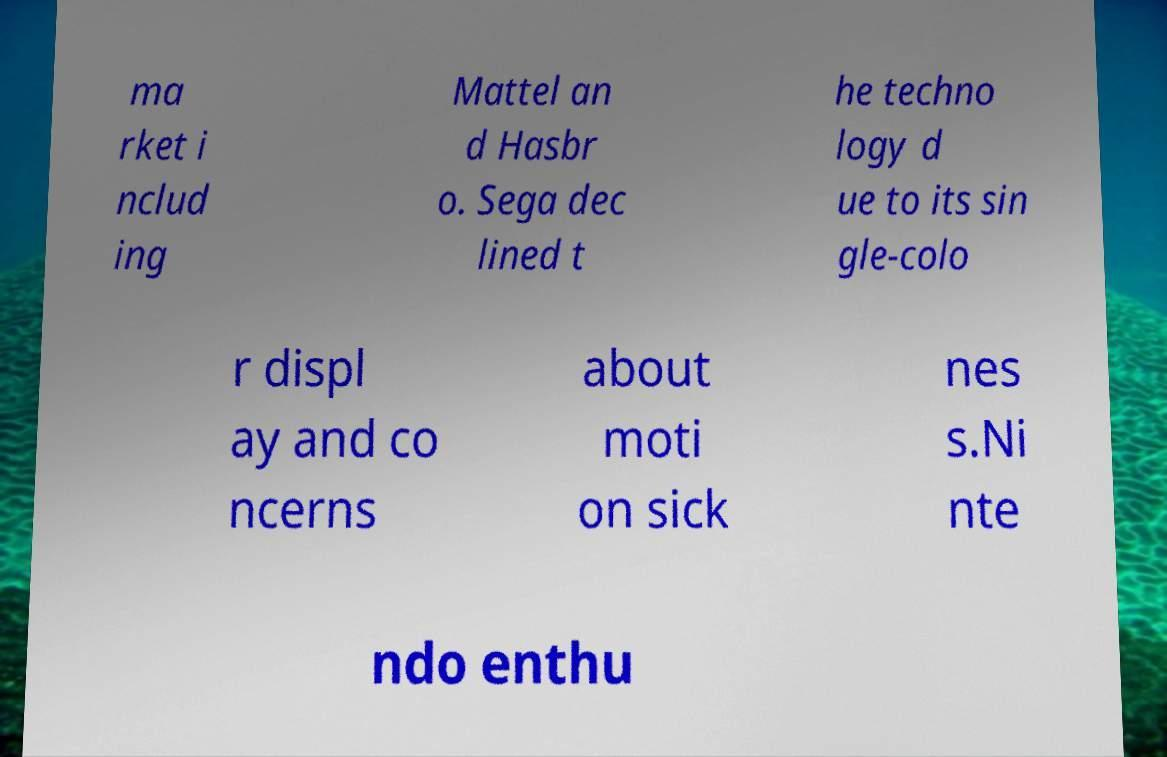There's text embedded in this image that I need extracted. Can you transcribe it verbatim? ma rket i nclud ing Mattel an d Hasbr o. Sega dec lined t he techno logy d ue to its sin gle-colo r displ ay and co ncerns about moti on sick nes s.Ni nte ndo enthu 